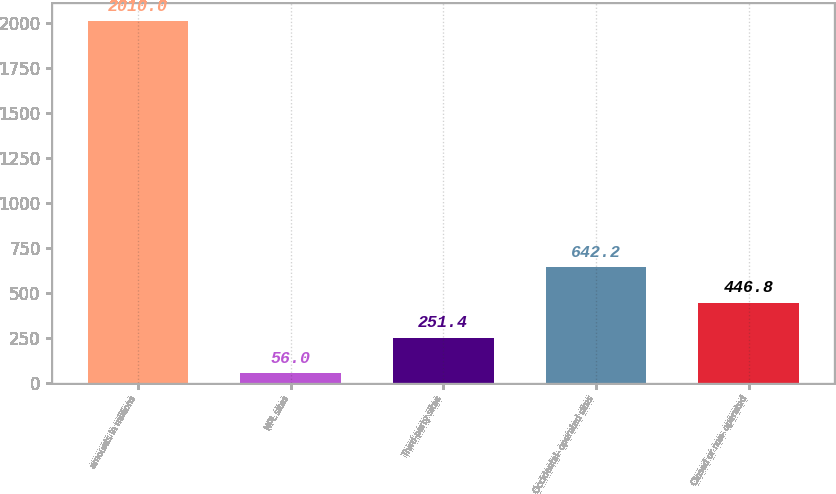<chart> <loc_0><loc_0><loc_500><loc_500><bar_chart><fcel>amounts in millions<fcel>NPL sites<fcel>Third-party sites<fcel>Occidental- operated sites<fcel>Closed or non- operated<nl><fcel>2010<fcel>56<fcel>251.4<fcel>642.2<fcel>446.8<nl></chart> 